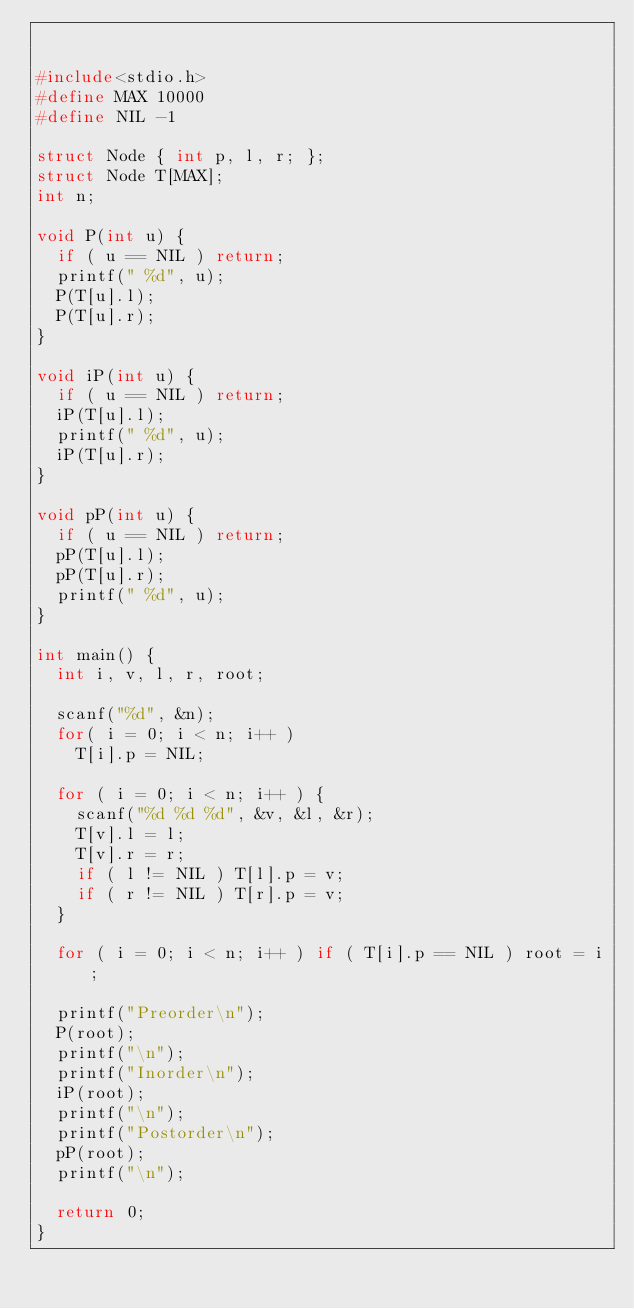<code> <loc_0><loc_0><loc_500><loc_500><_C_>

#include<stdio.h>
#define MAX 10000
#define NIL -1

struct Node { int p, l, r; };
struct Node T[MAX];
int n;

void P(int u) {
  if ( u == NIL ) return;
  printf(" %d", u);
  P(T[u].l);
  P(T[u].r);
}

void iP(int u) {
  if ( u == NIL ) return;
  iP(T[u].l);
  printf(" %d", u);
  iP(T[u].r);
}

void pP(int u) {
  if ( u == NIL ) return;
  pP(T[u].l);
  pP(T[u].r);
  printf(" %d", u);
}

int main() {
  int i, v, l, r, root;

  scanf("%d", &n);
  for( i = 0; i < n; i++ )
    T[i].p = NIL;

  for ( i = 0; i < n; i++ ) {
    scanf("%d %d %d", &v, &l, &r);
    T[v].l = l;
    T[v].r = r;
    if ( l != NIL ) T[l].p = v;
    if ( r != NIL ) T[r].p = v;
  }

  for ( i = 0; i < n; i++ ) if ( T[i].p == NIL ) root = i;

  printf("Preorder\n");
  P(root);
  printf("\n");
  printf("Inorder\n");
  iP(root);
  printf("\n");
  printf("Postorder\n");
  pP(root);
  printf("\n");

  return 0;
}

</code> 